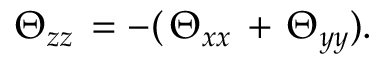Convert formula to latex. <formula><loc_0><loc_0><loc_500><loc_500>\begin{array} { r } { \Theta _ { z z } \, = - ( \, \Theta _ { x x } \, + \, \Theta _ { y y } ) . } \end{array}</formula> 